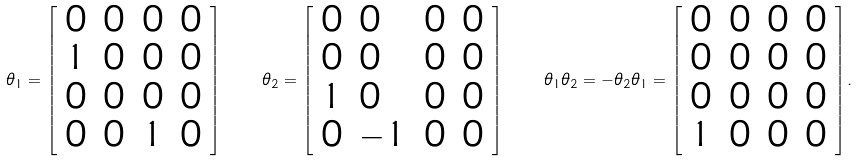Convert formula to latex. <formula><loc_0><loc_0><loc_500><loc_500>\theta _ { 1 } = { \left [ \begin{array} { l l l l } { 0 } & { 0 } & { 0 } & { 0 } \\ { 1 } & { 0 } & { 0 } & { 0 } \\ { 0 } & { 0 } & { 0 } & { 0 } \\ { 0 } & { 0 } & { 1 } & { 0 } \end{array} \right ] } \quad \theta _ { 2 } = { \left [ \begin{array} { l l l l } { 0 } & { 0 } & { 0 } & { 0 } \\ { 0 } & { 0 } & { 0 } & { 0 } \\ { 1 } & { 0 } & { 0 } & { 0 } \\ { 0 } & { - 1 } & { 0 } & { 0 } \end{array} \right ] } \quad \theta _ { 1 } \theta _ { 2 } = - \theta _ { 2 } \theta _ { 1 } = { \left [ \begin{array} { l l l l } { 0 } & { 0 } & { 0 } & { 0 } \\ { 0 } & { 0 } & { 0 } & { 0 } \\ { 0 } & { 0 } & { 0 } & { 0 } \\ { 1 } & { 0 } & { 0 } & { 0 } \end{array} \right ] } .</formula> 